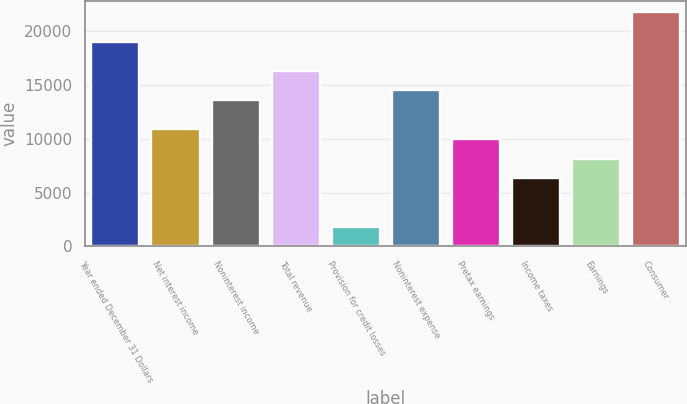<chart> <loc_0><loc_0><loc_500><loc_500><bar_chart><fcel>Year ended December 31 Dollars<fcel>Net interest income<fcel>Noninterest income<fcel>Total revenue<fcel>Provision for credit losses<fcel>Noninterest expense<fcel>Pretax earnings<fcel>Income taxes<fcel>Earnings<fcel>Consumer<nl><fcel>19012.3<fcel>10864.6<fcel>13580.5<fcel>16296.4<fcel>1811.6<fcel>14485.8<fcel>9959.3<fcel>6338.1<fcel>8148.7<fcel>21728.2<nl></chart> 